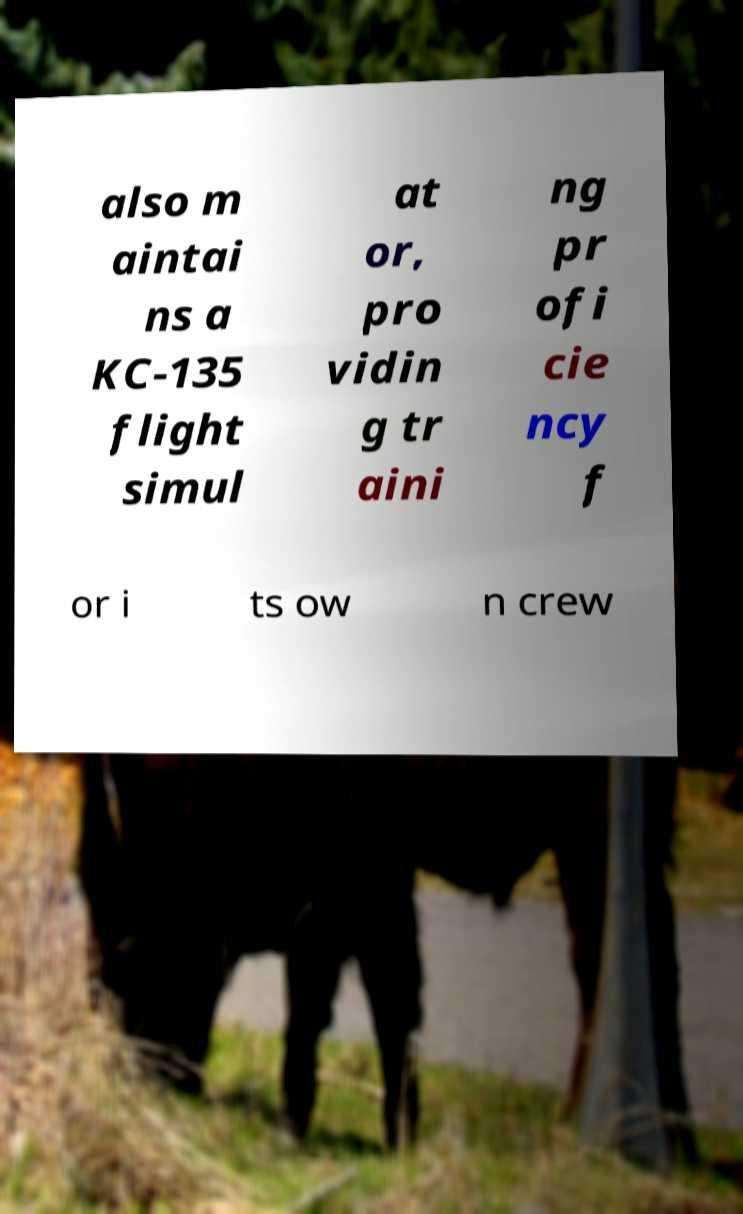There's text embedded in this image that I need extracted. Can you transcribe it verbatim? also m aintai ns a KC-135 flight simul at or, pro vidin g tr aini ng pr ofi cie ncy f or i ts ow n crew 